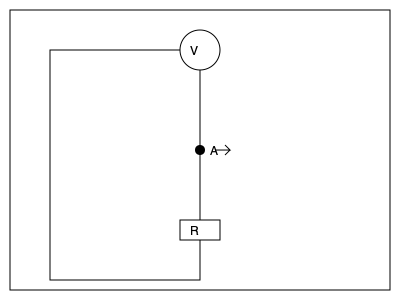In the simple circuit shown, an ammeter (A) measures the current flowing through a resistor (R) connected to a voltage source (V). If the voltage is doubled while keeping the resistance constant, how will the current change? Express your answer as a ratio of the new current to the original current. To understand how the current changes when the voltage is doubled, we need to follow these steps:

1) First, recall Ohm's Law, which states that:

   $$V = IR$$

   where $V$ is voltage, $I$ is current, and $R$ is resistance.

2) In the initial situation, let's call the voltage $V_1$ and the current $I_1$. We don't know their actual values, but we can write:

   $$V_1 = I_1R$$

3) When we double the voltage, the new voltage $V_2 = 2V_1$. Let's call the new current $I_2$. We can write:

   $$V_2 = I_2R = 2V_1$$

4) Substituting the expression for $V_1$ from step 2:

   $$I_2R = 2(I_1R)$$

5) Simplifying:

   $$I_2 = 2I_1$$

6) To express this as a ratio of new current to original current:

   $$\frac{I_2}{I_1} = \frac{2I_1}{I_1} = 2$$

Therefore, when the voltage is doubled and resistance remains constant, the current also doubles.
Answer: $2:1$ or $2$ 